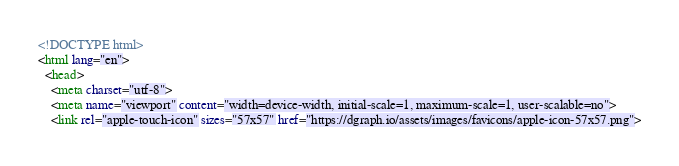<code> <loc_0><loc_0><loc_500><loc_500><_HTML_>



<!DOCTYPE html>
<html lang="en">
  <head>
    <meta charset="utf-8">
    <meta name="viewport" content="width=device-width, initial-scale=1, maximum-scale=1, user-scalable=no">
    <link rel="apple-touch-icon" sizes="57x57" href="https://dgraph.io/assets/images/favicons/apple-icon-57x57.png"></code> 